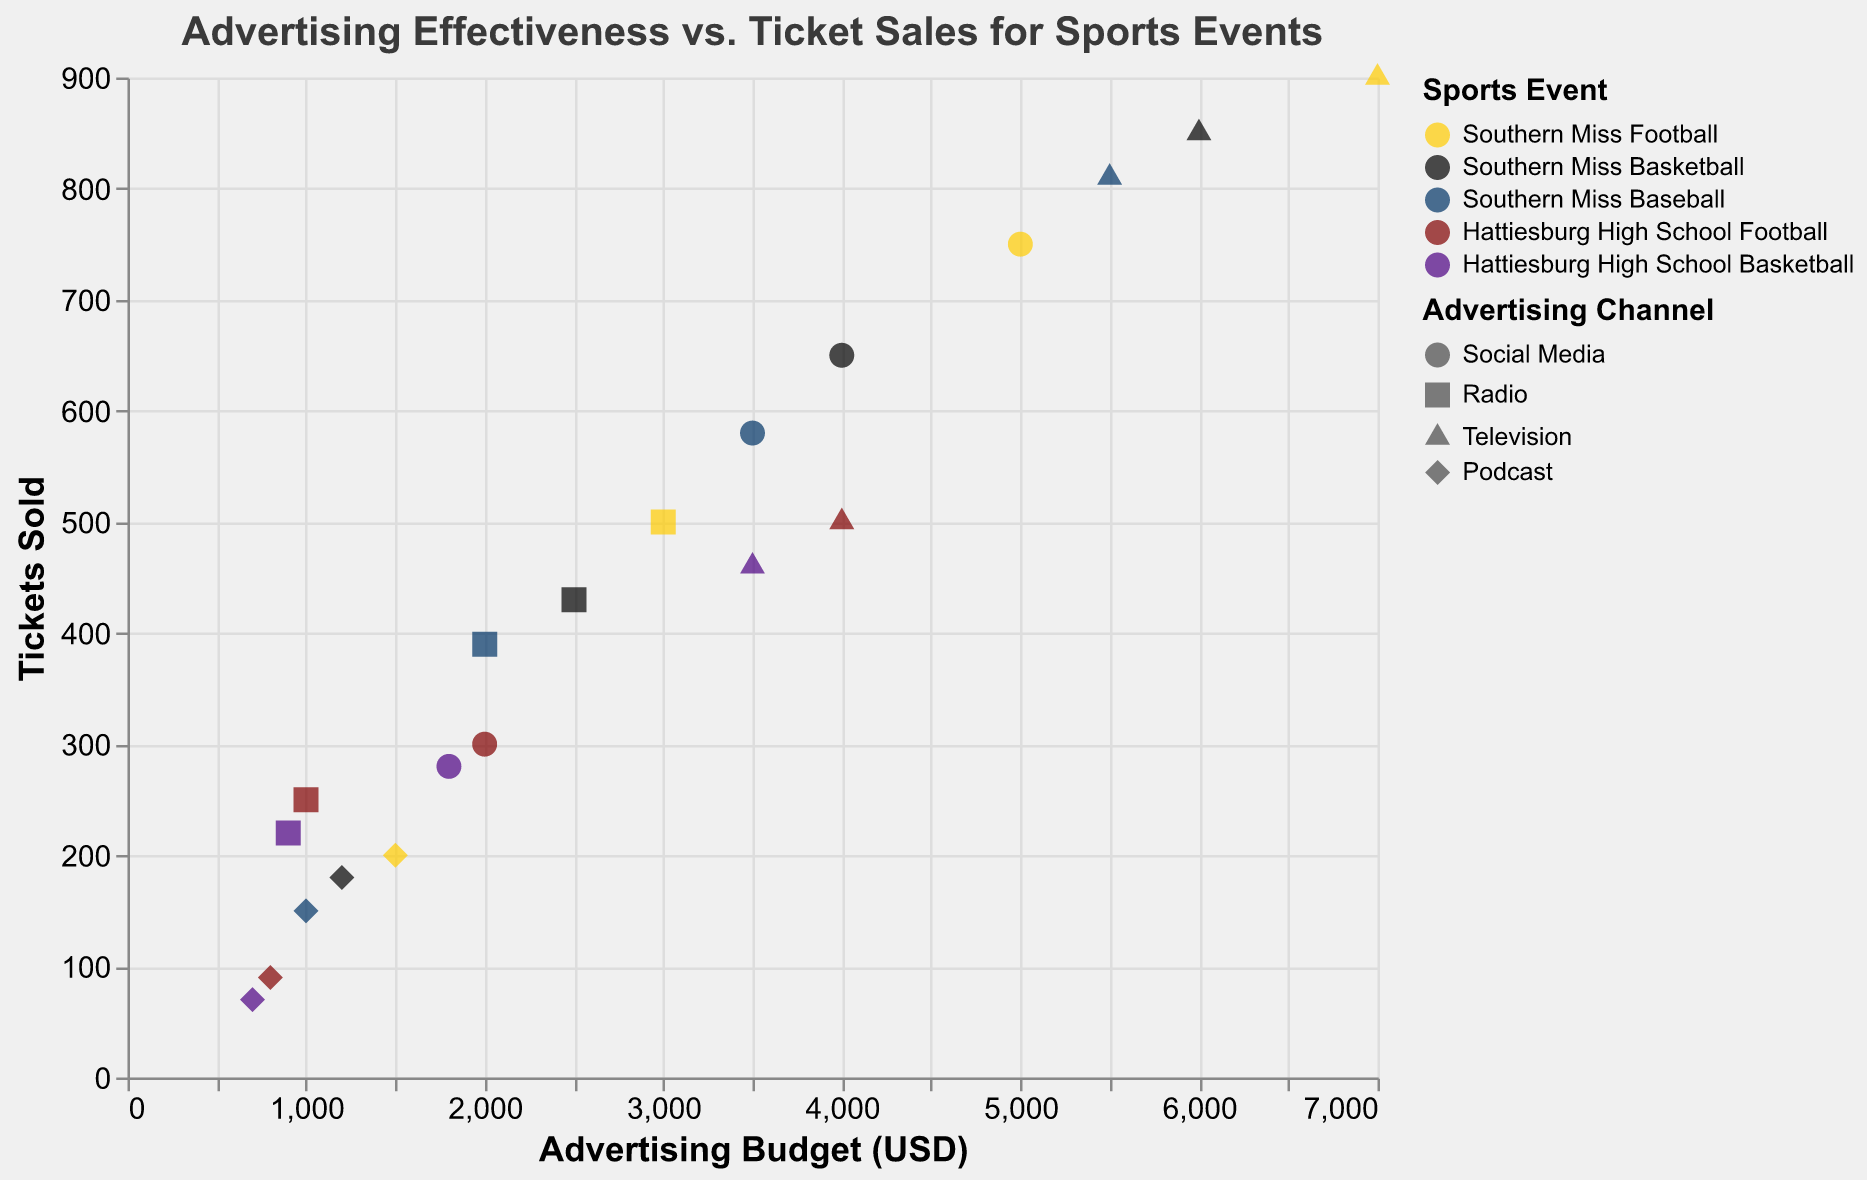What is the title of the plot? The title of the plot is located at the top center and reads "Advertising Effectiveness vs. Ticket Sales for Sports Events".
Answer: Advertising Effectiveness vs. Ticket Sales for Sports Events What does each point in the scatter plot represent? Each point represents a unique combination of an advertising channel, its budget, and the resulting number of tickets sold for a particular sports event.
Answer: An advertising channel, budget, and tickets sold for a sports event Which advertising channel seems to have generated the highest number of tickets sold for Southern Miss Football? By observing the points colored for Southern Miss Football events and identifying the maximum y-axis value (Tickets Sold), the Television channel has the highest ticket sales at 900.
Answer: Television How many data points are related to Hattiesburg High School Basketball? By counting the points associated with the color corresponding to Hattiesburg High School Basketball, there are four data points.
Answer: 4 Which event had the lowest ticket sales through Podcast advertising, and how many tickets were sold? By looking at the shape representing Podcast and finding the minimum y-axis value, Hattiesburg High School Basketball sold the fewest tickets through Podcast with 70 tickets.
Answer: Hattiesburg High School Basketball, 70 Compare the efficiency of Social Media and Radio for Southern Miss Basketball in terms of tickets sold per dollar spent. Which is more efficient? Calculate the ratio of tickets sold to budget for Social Media (650/4000 = 0.1625) and Radio (430/2500 = 0.172). Radio is more efficient with a higher ratio.
Answer: Radio What is the range of advertising budgets used for Southern Miss Baseball? Identify the minimum and maximum x-axis values for the points colored for Southern Miss Baseball. The budgets range from 1000 to 5500 USD.
Answer: 1000 to 5500 USD Among the social media advertising channels, which sports event had the highest number of tickets sold and how many? Examining the circular points since they represent Social Media and identifying the highest y-axis value, Southern Miss Football had the most with 750 tickets sold.
Answer: Southern Miss Football, 750 What is the total number of tickets sold through Radio advertising for all events combined? Sum the y-values (Tickets Sold) of all square-shaped points: 500 + 430 + 390 + 250 + 220 = 1790 tickets.
Answer: 1790 Which event has the most disparate ticket sales between its highest and lowest advertising channels? Assess the range in y-axis values for different shapes within each event. Southern Miss Football shows a wide range, from Television (900) to Podcast (200), a difference of 700 tickets.
Answer: Southern Miss Football, 700 